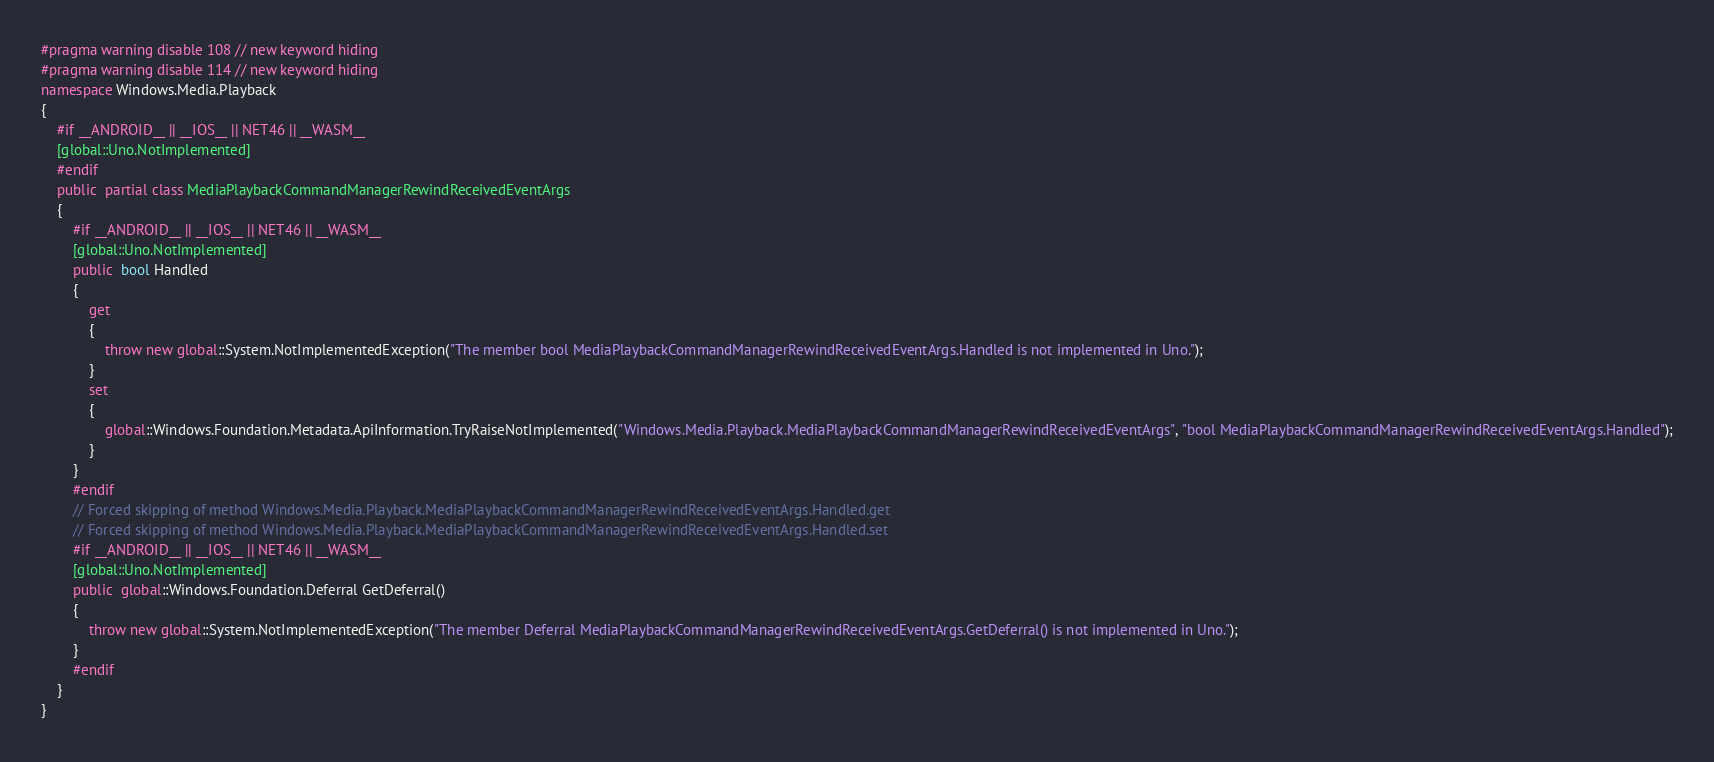<code> <loc_0><loc_0><loc_500><loc_500><_C#_>#pragma warning disable 108 // new keyword hiding
#pragma warning disable 114 // new keyword hiding
namespace Windows.Media.Playback
{
	#if __ANDROID__ || __IOS__ || NET46 || __WASM__
	[global::Uno.NotImplemented]
	#endif
	public  partial class MediaPlaybackCommandManagerRewindReceivedEventArgs 
	{
		#if __ANDROID__ || __IOS__ || NET46 || __WASM__
		[global::Uno.NotImplemented]
		public  bool Handled
		{
			get
			{
				throw new global::System.NotImplementedException("The member bool MediaPlaybackCommandManagerRewindReceivedEventArgs.Handled is not implemented in Uno.");
			}
			set
			{
				global::Windows.Foundation.Metadata.ApiInformation.TryRaiseNotImplemented("Windows.Media.Playback.MediaPlaybackCommandManagerRewindReceivedEventArgs", "bool MediaPlaybackCommandManagerRewindReceivedEventArgs.Handled");
			}
		}
		#endif
		// Forced skipping of method Windows.Media.Playback.MediaPlaybackCommandManagerRewindReceivedEventArgs.Handled.get
		// Forced skipping of method Windows.Media.Playback.MediaPlaybackCommandManagerRewindReceivedEventArgs.Handled.set
		#if __ANDROID__ || __IOS__ || NET46 || __WASM__
		[global::Uno.NotImplemented]
		public  global::Windows.Foundation.Deferral GetDeferral()
		{
			throw new global::System.NotImplementedException("The member Deferral MediaPlaybackCommandManagerRewindReceivedEventArgs.GetDeferral() is not implemented in Uno.");
		}
		#endif
	}
}
</code> 